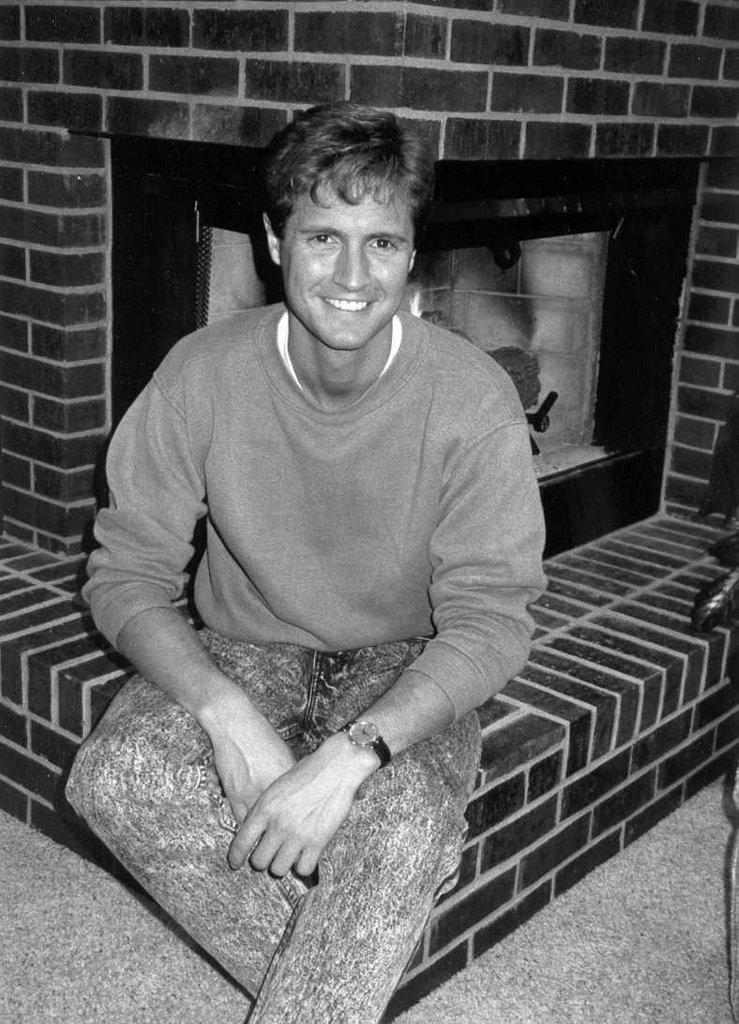Who is present in the image? There is a man in the image. What is the man doing in the image? The man is sitting on a pavement. What type of flag is the man holding while reading in the image? There is no flag or reading material present in the image; the man is simply sitting on a pavement. 